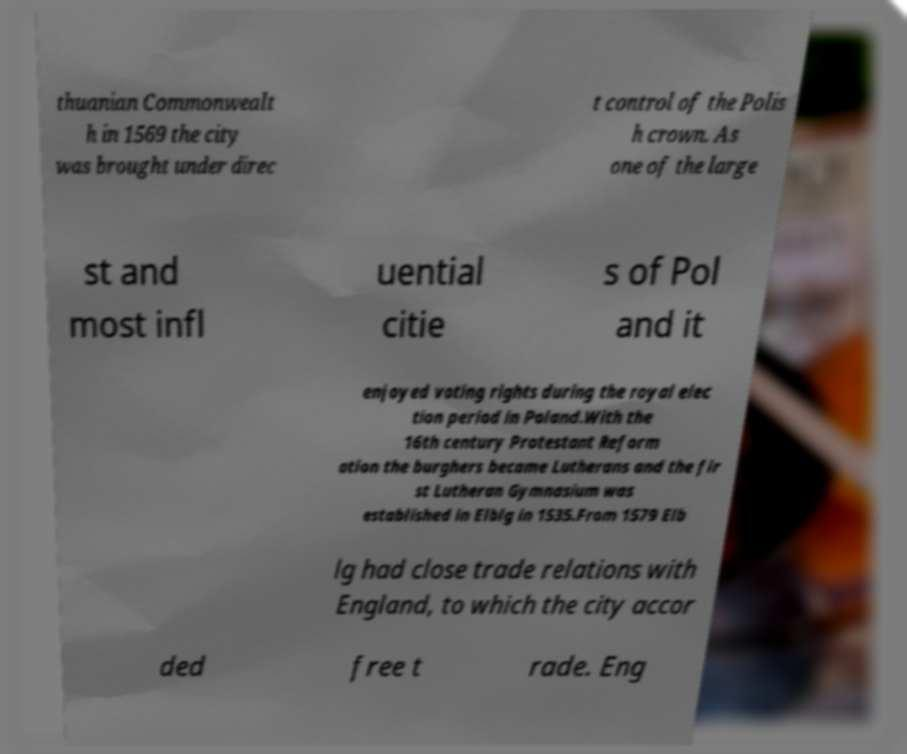Could you assist in decoding the text presented in this image and type it out clearly? thuanian Commonwealt h in 1569 the city was brought under direc t control of the Polis h crown. As one of the large st and most infl uential citie s of Pol and it enjoyed voting rights during the royal elec tion period in Poland.With the 16th century Protestant Reform ation the burghers became Lutherans and the fir st Lutheran Gymnasium was established in Elblg in 1535.From 1579 Elb lg had close trade relations with England, to which the city accor ded free t rade. Eng 